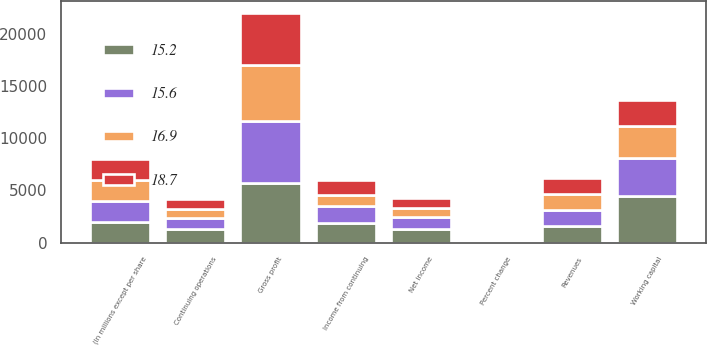<chart> <loc_0><loc_0><loc_500><loc_500><stacked_bar_chart><ecel><fcel>(In millions except per share<fcel>Revenues<fcel>Percent change<fcel>Gross profit<fcel>Income from continuing<fcel>Continuing operations<fcel>Net income<fcel>Working capital<nl><fcel>15.6<fcel>2011<fcel>1546<fcel>3.1<fcel>5970<fcel>1635<fcel>1130<fcel>1202<fcel>3631<nl><fcel>15.2<fcel>2010<fcel>1546<fcel>1.9<fcel>5676<fcel>1864<fcel>1263<fcel>1263<fcel>4492<nl><fcel>16.9<fcel>2009<fcel>1546<fcel>4.8<fcel>5378<fcel>1064<fcel>823<fcel>823<fcel>3065<nl><fcel>18.7<fcel>2008<fcel>1546<fcel>9.4<fcel>5009<fcel>1457<fcel>989<fcel>990<fcel>2438<nl></chart> 